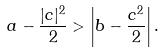<formula> <loc_0><loc_0><loc_500><loc_500>a - \frac { | c | ^ { 2 } } { 2 } > \left | b - \frac { c ^ { 2 } } { 2 } \right | .</formula> 